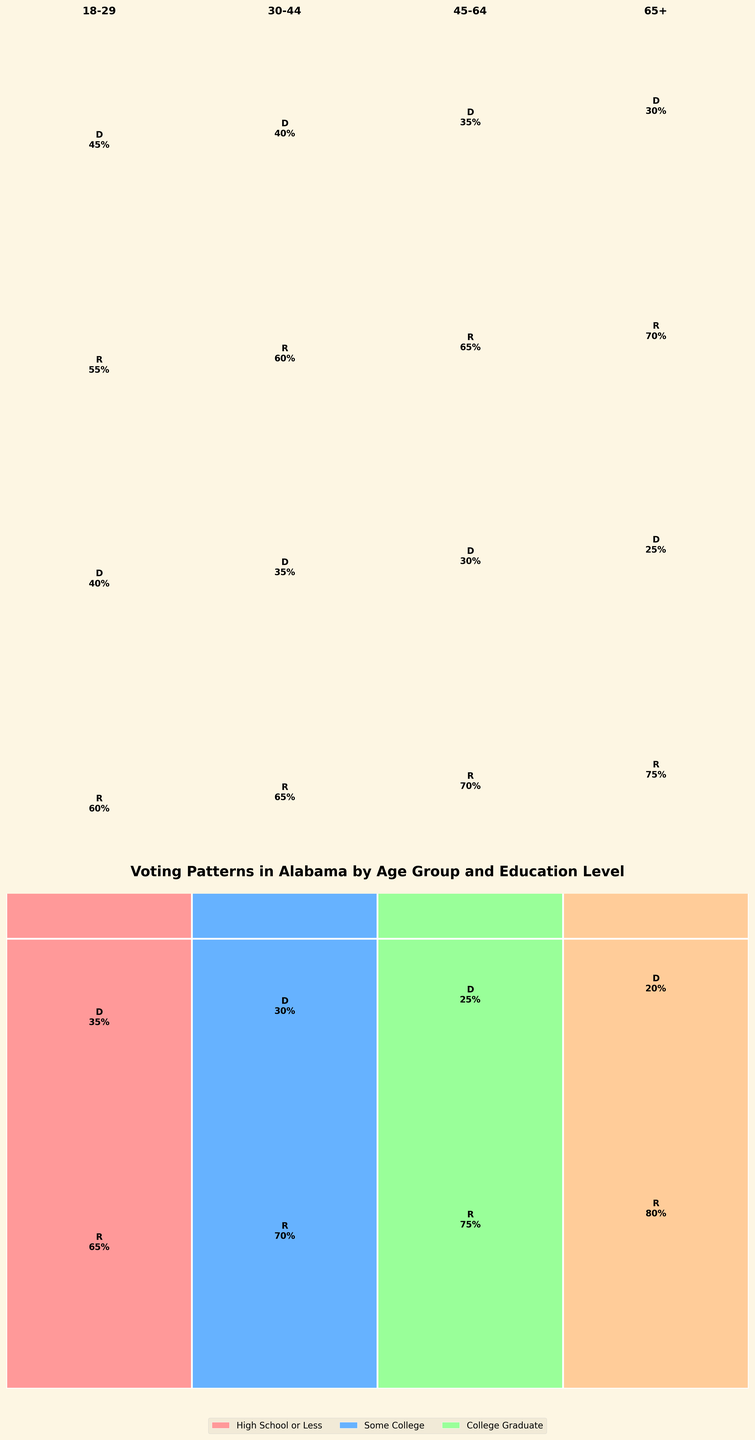What is the title of the figure? The title of the figure is located at the top. It directly states the subject of the plot.
Answer: Voting Patterns in Alabama by Age Group and Education Level What colors represent the different education levels? The legends at the bottom identify each education level with a specific color.
Answer: #FF9999, #66B2FF, #99FF99, #FFCC99 Which age group has the highest percentage of Republican voters? By observing the heights of the colored rectangles representing Republican voters for each age group, the highest one can be identified.
Answer: 65+ Which education level shows the smallest difference between Republican and Democrat votes for the 18-29 age group? By comparing the height of the rectangles representing each type of vote for the 18-29 age group, we determine the smallest difference.
Answer: College Graduate How many total votes were there for the 30-44 age group with Some College education? Add the number of Republican and Democrat votes for the specified group.
Answer: 65 + 35 = 100 How does the voting pattern for College Graduates change with age? For each age group, observe the differences in the rectangle heights for College Graduates and note the trend.
Answer: Older age groups have higher percentages of Republican votes Compare the voting patterns of high school or less education levels across age groups. Look at the heights of the red and blue rectangles for each age group and summarize the trend.
Answer: Republican votes increase with age Which education level has the most balanced voting pattern in the 45-64 age group? Check the heights of the rectangles representing Republican and Democrat votes and find the most balanced ones.
Answer: College Graduate Which age group has the highest percentage of Democrat voters? Find the age group with the tallest blue rectangle.
Answer: 18-29 Which group: 30-44 with High School or Less or 65+ with Some College, has a higher percentage of Democrat voters? Compare the heights of the blue rectangles for the specified groups.
Answer: 30-44 with High School or Less 